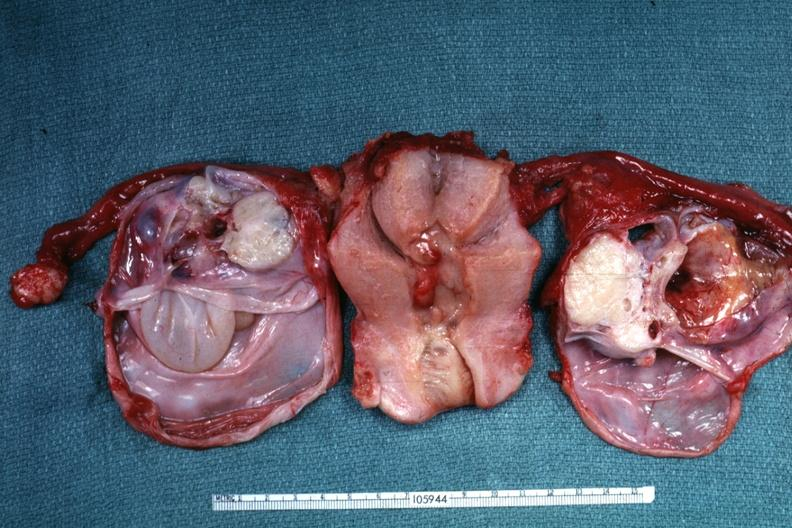s lesion of myocytolysis present?
Answer the question using a single word or phrase. No 